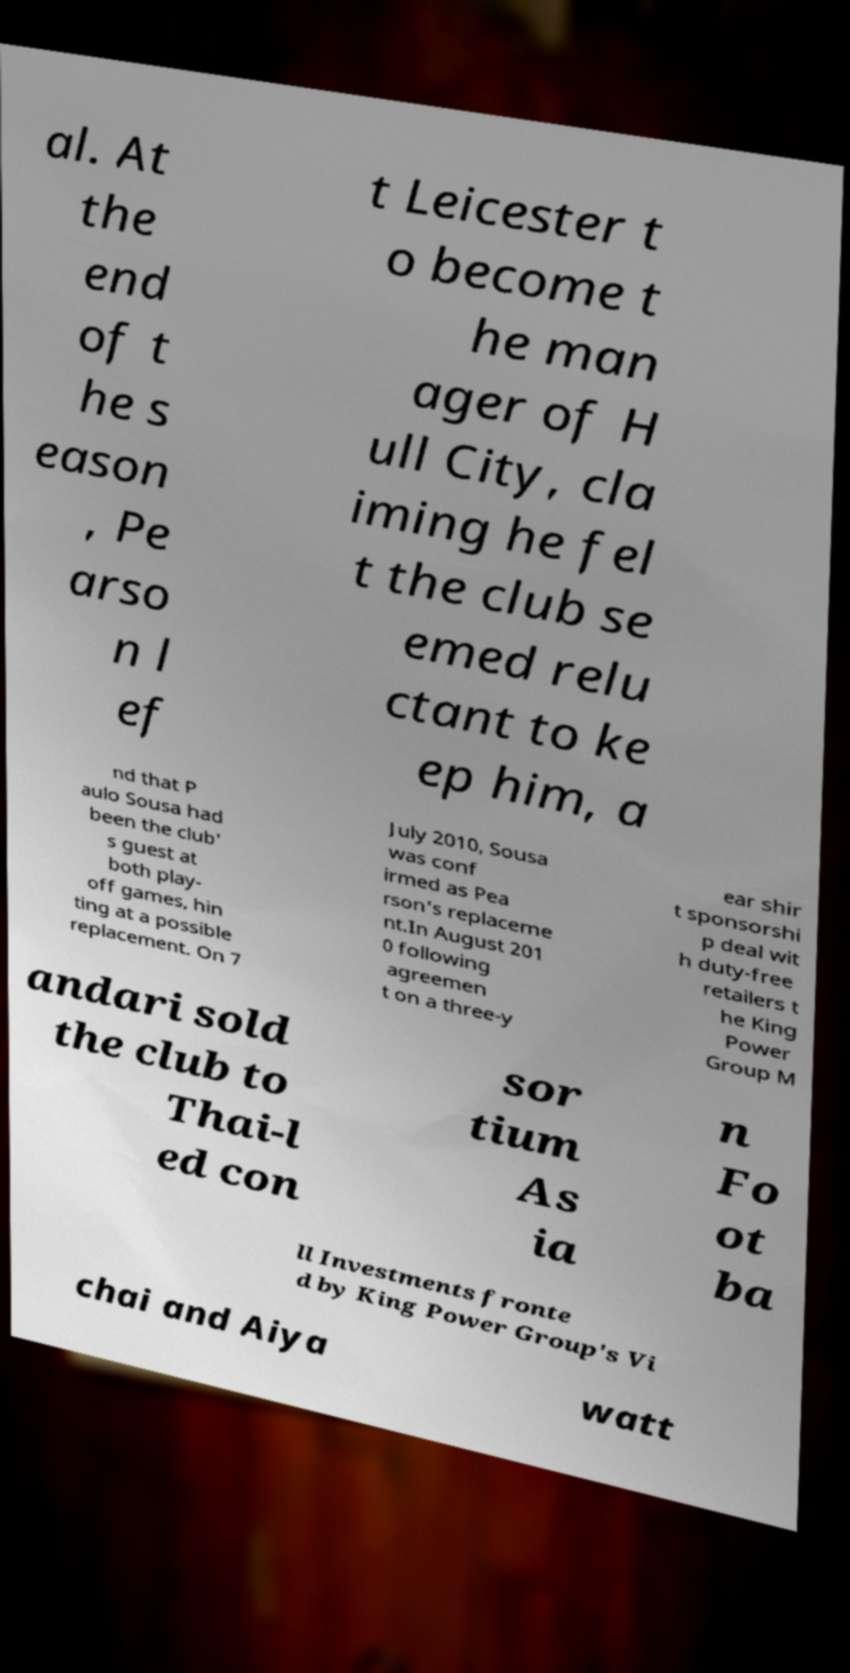There's text embedded in this image that I need extracted. Can you transcribe it verbatim? al. At the end of t he s eason , Pe arso n l ef t Leicester t o become t he man ager of H ull City, cla iming he fel t the club se emed relu ctant to ke ep him, a nd that P aulo Sousa had been the club' s guest at both play- off games, hin ting at a possible replacement. On 7 July 2010, Sousa was conf irmed as Pea rson's replaceme nt.In August 201 0 following agreemen t on a three-y ear shir t sponsorshi p deal wit h duty-free retailers t he King Power Group M andari sold the club to Thai-l ed con sor tium As ia n Fo ot ba ll Investments fronte d by King Power Group's Vi chai and Aiya watt 